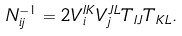Convert formula to latex. <formula><loc_0><loc_0><loc_500><loc_500>N ^ { - 1 } _ { i j } = 2 V ^ { I K } _ { i } V ^ { J L } _ { j } T _ { I J } T _ { K L } .</formula> 